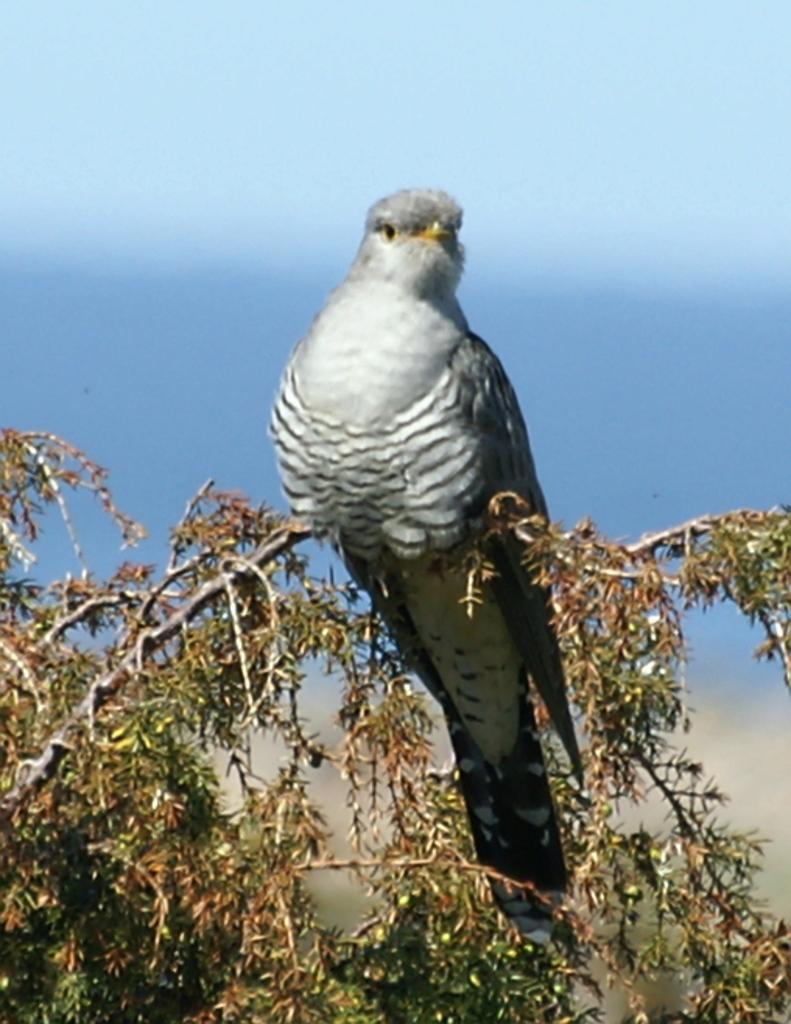Could you give a brief overview of what you see in this image? In this picture I can see a bird on the tree and a blue cloudy sky in the background. 